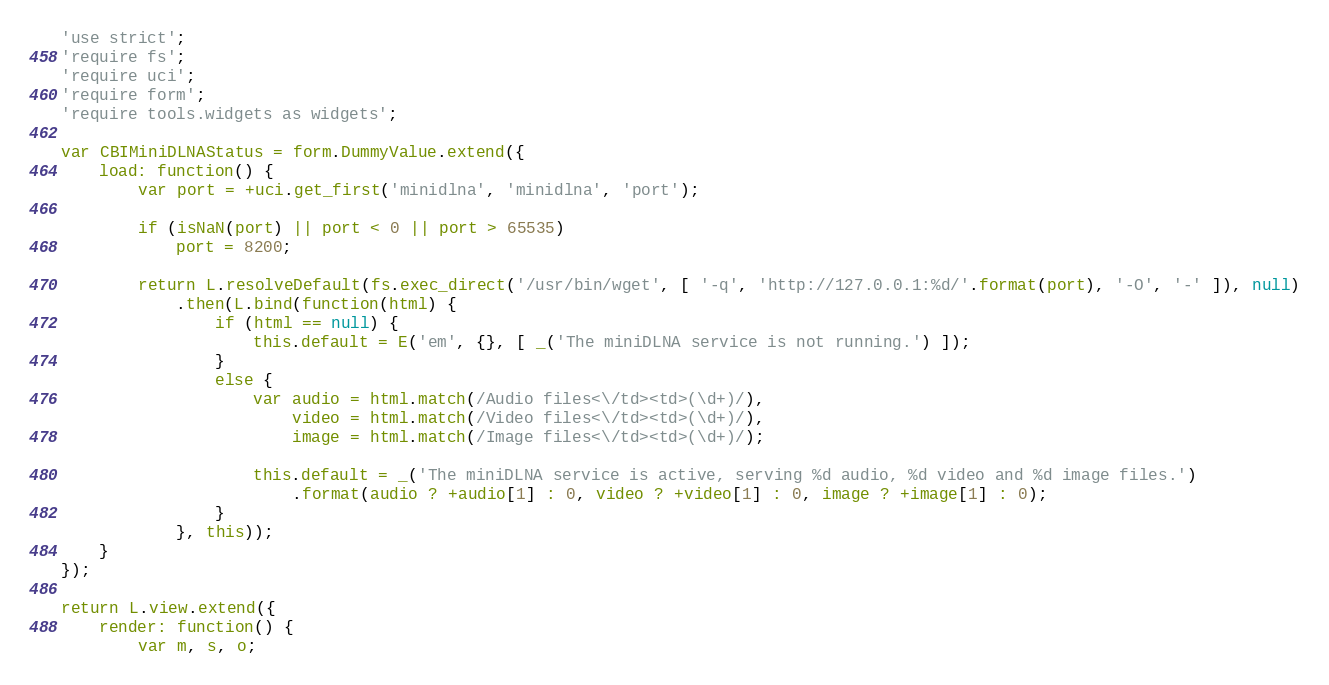<code> <loc_0><loc_0><loc_500><loc_500><_JavaScript_>'use strict';
'require fs';
'require uci';
'require form';
'require tools.widgets as widgets';

var CBIMiniDLNAStatus = form.DummyValue.extend({
	load: function() {
		var port = +uci.get_first('minidlna', 'minidlna', 'port');

		if (isNaN(port) || port < 0 || port > 65535)
			port = 8200;

		return L.resolveDefault(fs.exec_direct('/usr/bin/wget', [ '-q', 'http://127.0.0.1:%d/'.format(port), '-O', '-' ]), null)
			.then(L.bind(function(html) {
				if (html == null) {
					this.default = E('em', {}, [ _('The miniDLNA service is not running.') ]);
				}
				else {
					var audio = html.match(/Audio files<\/td><td>(\d+)/),
					    video = html.match(/Video files<\/td><td>(\d+)/),
					    image = html.match(/Image files<\/td><td>(\d+)/);

					this.default = _('The miniDLNA service is active, serving %d audio, %d video and %d image files.')
						.format(audio ? +audio[1] : 0, video ? +video[1] : 0, image ? +image[1] : 0);
				}
			}, this));
	}
});

return L.view.extend({
	render: function() {
		var m, s, o;
</code> 